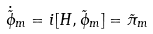<formula> <loc_0><loc_0><loc_500><loc_500>\dot { \tilde { \phi } } _ { m } = i [ H , \tilde { \phi } _ { m } ] = \tilde { \pi } _ { m }</formula> 